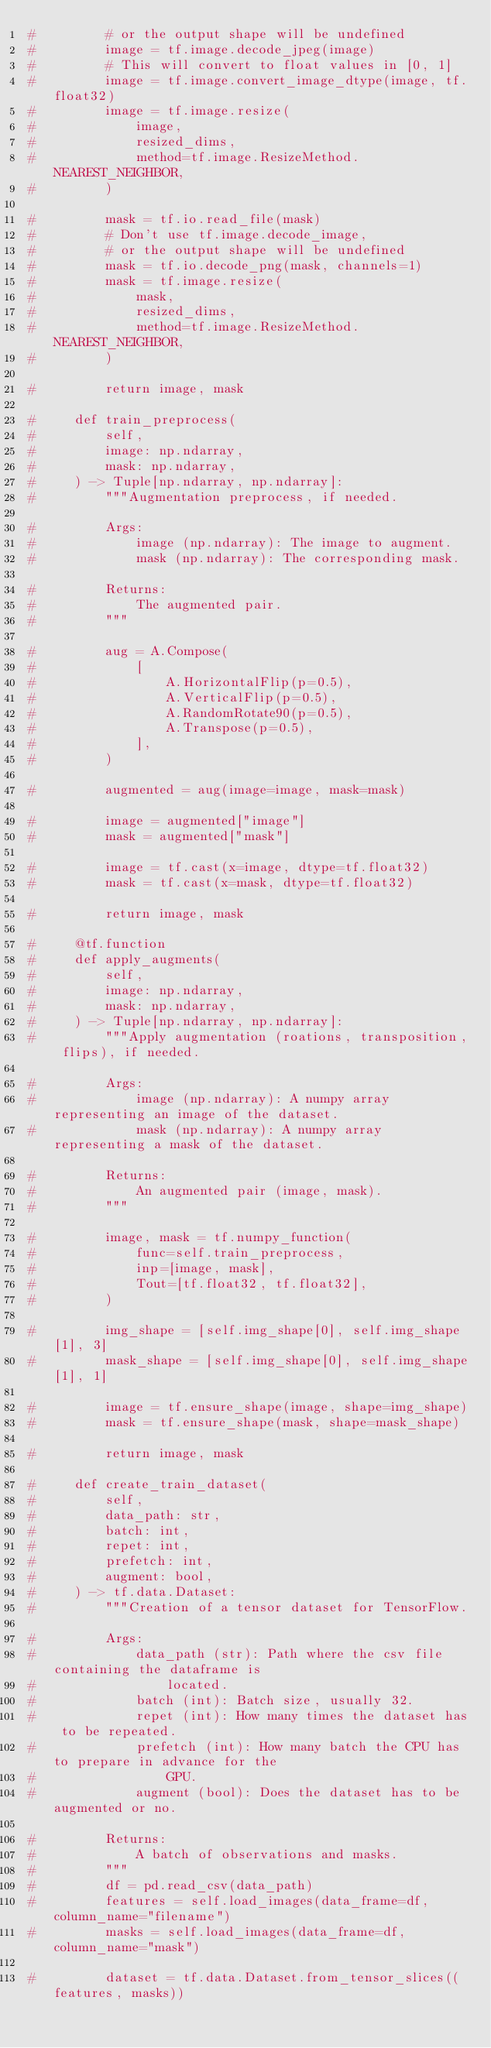Convert code to text. <code><loc_0><loc_0><loc_500><loc_500><_Python_>#         # or the output shape will be undefined
#         image = tf.image.decode_jpeg(image)
#         # This will convert to float values in [0, 1]
#         image = tf.image.convert_image_dtype(image, tf.float32)
#         image = tf.image.resize(
#             image,
#             resized_dims,
#             method=tf.image.ResizeMethod.NEAREST_NEIGHBOR,
#         )

#         mask = tf.io.read_file(mask)
#         # Don't use tf.image.decode_image,
#         # or the output shape will be undefined
#         mask = tf.io.decode_png(mask, channels=1)
#         mask = tf.image.resize(
#             mask,
#             resized_dims,
#             method=tf.image.ResizeMethod.NEAREST_NEIGHBOR,
#         )

#         return image, mask

#     def train_preprocess(
#         self,
#         image: np.ndarray,
#         mask: np.ndarray,
#     ) -> Tuple[np.ndarray, np.ndarray]:
#         """Augmentation preprocess, if needed.

#         Args:
#             image (np.ndarray): The image to augment.
#             mask (np.ndarray): The corresponding mask.

#         Returns:
#             The augmented pair.
#         """

#         aug = A.Compose(
#             [
#                 A.HorizontalFlip(p=0.5),
#                 A.VerticalFlip(p=0.5),
#                 A.RandomRotate90(p=0.5),
#                 A.Transpose(p=0.5),
#             ],
#         )

#         augmented = aug(image=image, mask=mask)

#         image = augmented["image"]
#         mask = augmented["mask"]

#         image = tf.cast(x=image, dtype=tf.float32)
#         mask = tf.cast(x=mask, dtype=tf.float32)

#         return image, mask

#     @tf.function
#     def apply_augments(
#         self,
#         image: np.ndarray,
#         mask: np.ndarray,
#     ) -> Tuple[np.ndarray, np.ndarray]:
#         """Apply augmentation (roations, transposition, flips), if needed.

#         Args:
#             image (np.ndarray): A numpy array representing an image of the dataset.
#             mask (np.ndarray): A numpy array representing a mask of the dataset.

#         Returns:
#             An augmented pair (image, mask).
#         """

#         image, mask = tf.numpy_function(
#             func=self.train_preprocess,
#             inp=[image, mask],
#             Tout=[tf.float32, tf.float32],
#         )

#         img_shape = [self.img_shape[0], self.img_shape[1], 3]
#         mask_shape = [self.img_shape[0], self.img_shape[1], 1]

#         image = tf.ensure_shape(image, shape=img_shape)
#         mask = tf.ensure_shape(mask, shape=mask_shape)

#         return image, mask

#     def create_train_dataset(
#         self,
#         data_path: str,
#         batch: int,
#         repet: int,
#         prefetch: int,
#         augment: bool,
#     ) -> tf.data.Dataset:
#         """Creation of a tensor dataset for TensorFlow.

#         Args:
#             data_path (str): Path where the csv file containing the dataframe is
#                 located.
#             batch (int): Batch size, usually 32.
#             repet (int): How many times the dataset has to be repeated.
#             prefetch (int): How many batch the CPU has to prepare in advance for the
#                 GPU.
#             augment (bool): Does the dataset has to be augmented or no.

#         Returns:
#             A batch of observations and masks.
#         """
#         df = pd.read_csv(data_path)
#         features = self.load_images(data_frame=df, column_name="filename")
#         masks = self.load_images(data_frame=df, column_name="mask")

#         dataset = tf.data.Dataset.from_tensor_slices((features, masks))</code> 